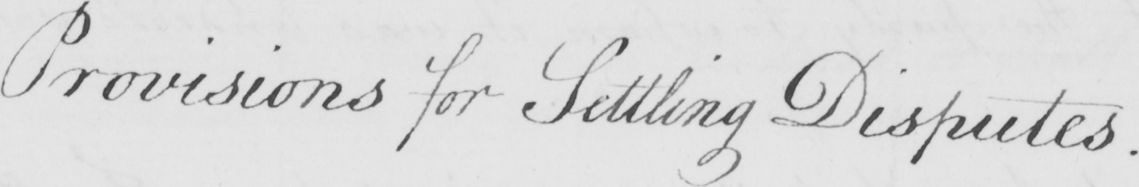What is written in this line of handwriting? Provisions for Settling Disputes . 